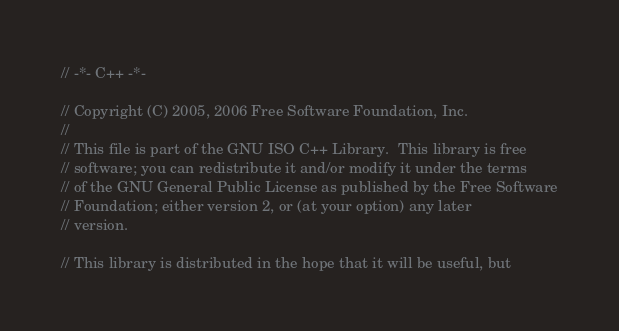<code> <loc_0><loc_0><loc_500><loc_500><_C++_>// -*- C++ -*-

// Copyright (C) 2005, 2006 Free Software Foundation, Inc.
//
// This file is part of the GNU ISO C++ Library.  This library is free
// software; you can redistribute it and/or modify it under the terms
// of the GNU General Public License as published by the Free Software
// Foundation; either version 2, or (at your option) any later
// version.

// This library is distributed in the hope that it will be useful, but</code> 